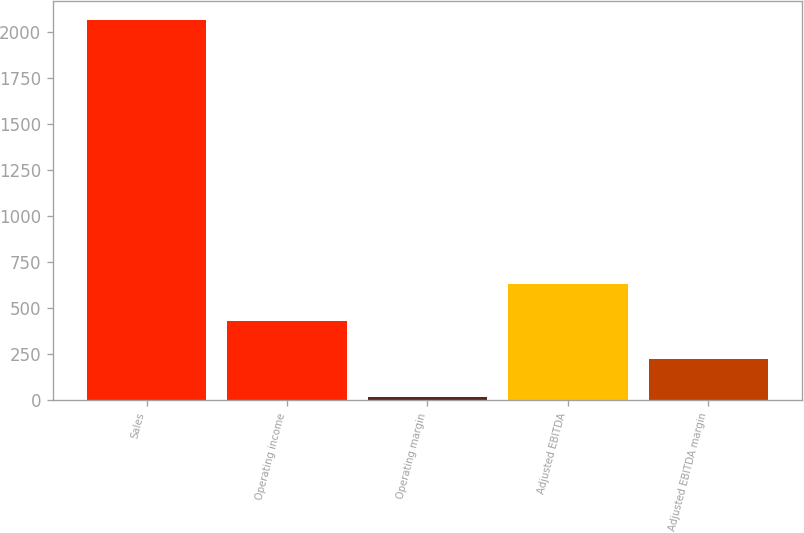<chart> <loc_0><loc_0><loc_500><loc_500><bar_chart><fcel>Sales<fcel>Operating income<fcel>Operating margin<fcel>Adjusted EBITDA<fcel>Adjusted EBITDA margin<nl><fcel>2064.6<fcel>427.64<fcel>18.4<fcel>632.26<fcel>223.02<nl></chart> 